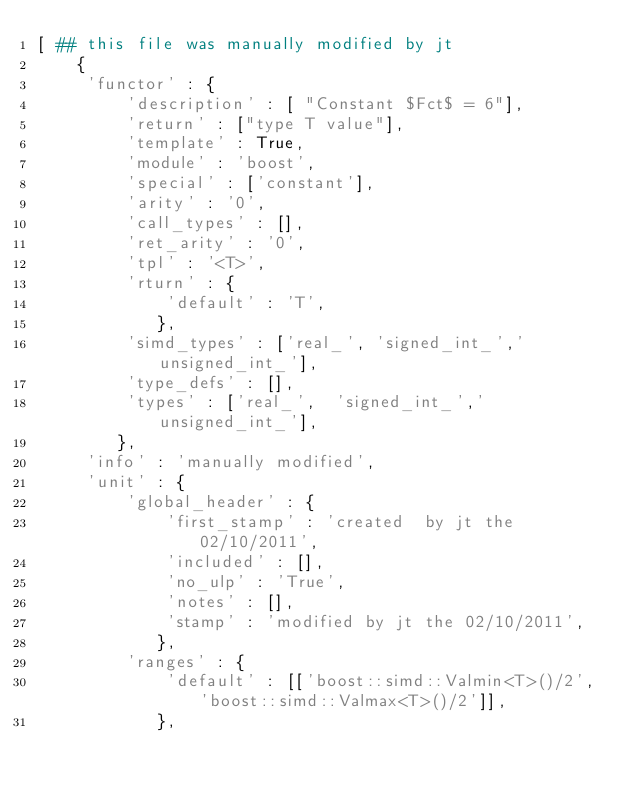<code> <loc_0><loc_0><loc_500><loc_500><_Python_>[ ## this file was manually modified by jt
    {
     'functor' : {
         'description' : [ "Constant $Fct$ = 6"],
         'return' : ["type T value"],
         'template' : True,
         'module' : 'boost',
         'special' : ['constant'],
         'arity' : '0',
         'call_types' : [],
         'ret_arity' : '0',
         'tpl' : '<T>',
         'rturn' : {
             'default' : 'T',
            },
         'simd_types' : ['real_', 'signed_int_','unsigned_int_'],
         'type_defs' : [],
         'types' : ['real_',  'signed_int_','unsigned_int_'],
        },
     'info' : 'manually modified',
     'unit' : {
         'global_header' : {
             'first_stamp' : 'created  by jt the 02/10/2011',
             'included' : [],
             'no_ulp' : 'True',
             'notes' : [],
             'stamp' : 'modified by jt the 02/10/2011',
            },
         'ranges' : {
             'default' : [['boost::simd::Valmin<T>()/2', 'boost::simd::Valmax<T>()/2']],
            },</code> 